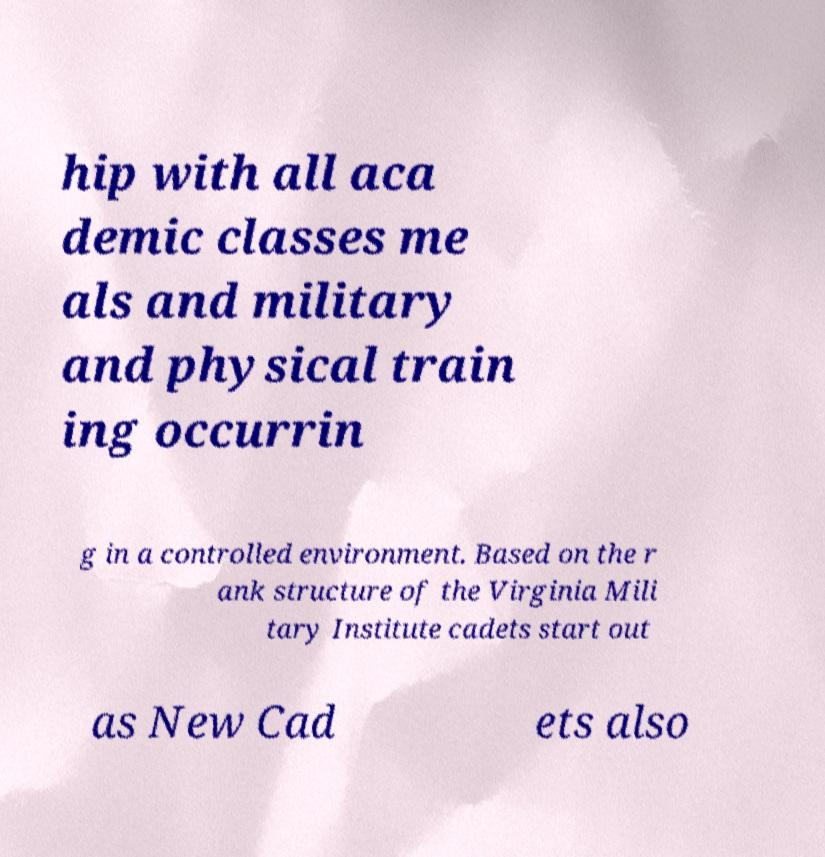Please read and relay the text visible in this image. What does it say? hip with all aca demic classes me als and military and physical train ing occurrin g in a controlled environment. Based on the r ank structure of the Virginia Mili tary Institute cadets start out as New Cad ets also 